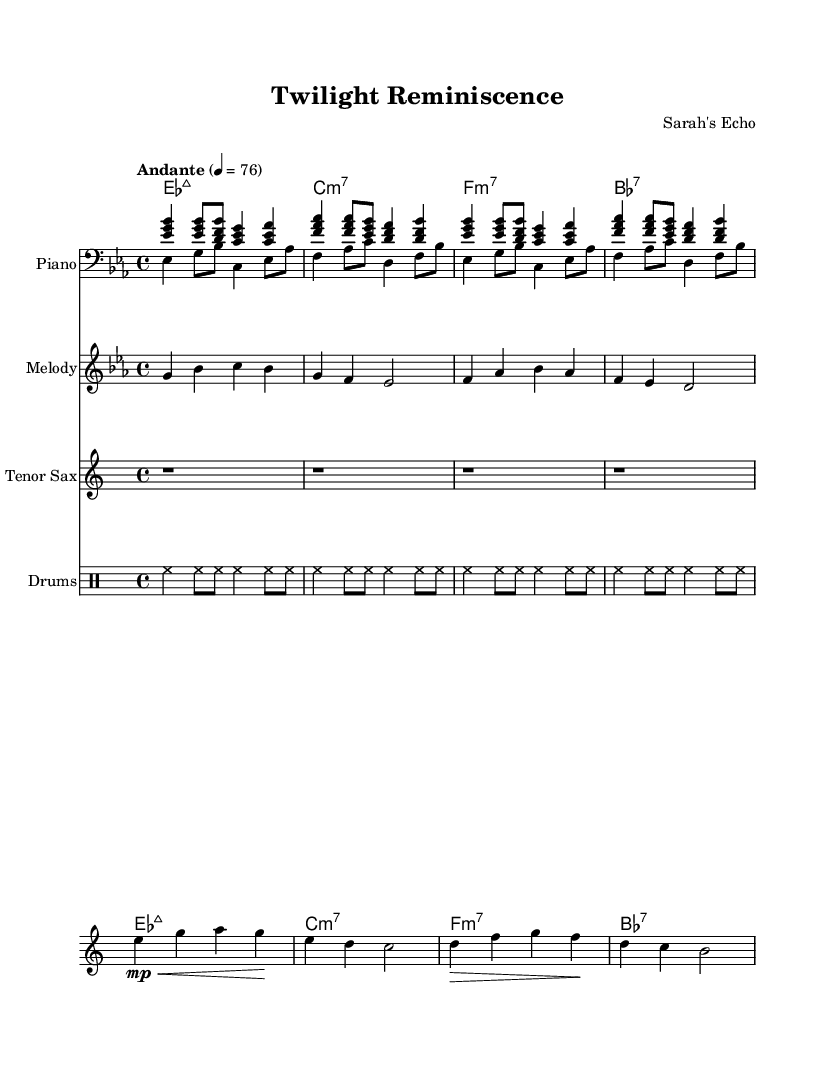What is the key signature of this music? The key signature indicated at the beginning of the score shows two flats, which corresponds to E flat major.
Answer: E flat major What is the time signature of this music? The time signature appears at the start of the composition, displaying a 4 over 4 configuration, which denotes common time.
Answer: 4/4 What tempo is indicated in this piece? The tempo marking "Andante" is displayed in the header section of the score, providing a clear guideline for the performance speed.
Answer: Andante How many measures are in each phrase of the piano part? Analyzing the piano section shows that each phrase contains four measures, as can be seen in the repeating structure of the music notation.
Answer: Four measures Which instrument plays the melody? The melody is specified in the score as being played by the staff labeled “Melody,” indicating its role throughout the piece.
Answer: Melody What type of chords are featured in this composition? The chord names listed in chord mode indicate the presence of seventh chords, specifically mentioning major seven and minor seven chords, typical in R&B music.
Answer: Seventh chords What is the role of the drums in this piece? The drum part consistently features a pattern that maintains a steady pulse and enhances the rhythmic drive of the piece, which is a staple in rhythm and blues genres.
Answer: Steady pulse 